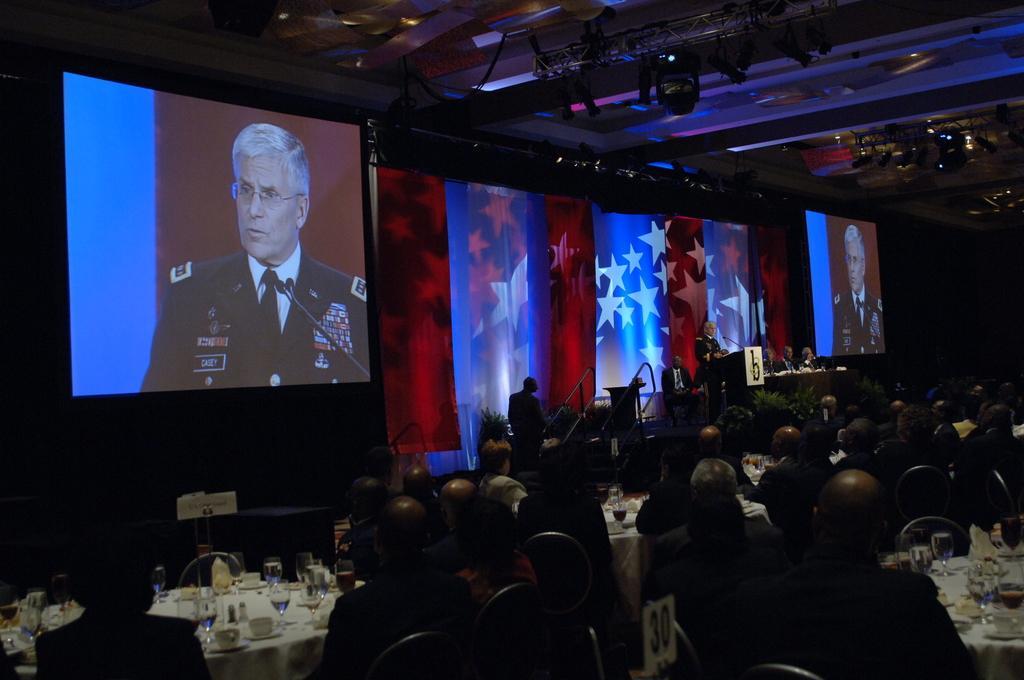In one or two sentences, can you explain what this image depicts? As we can see in the image there are screens, group of people sitting on chairs, projector and there are tables. On tables there are glasses and tissue. 